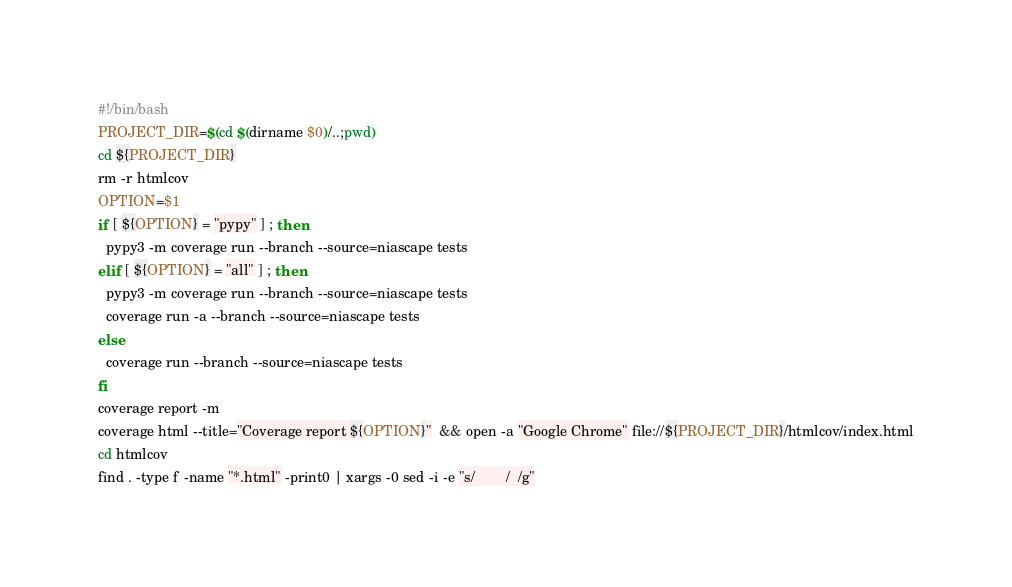<code> <loc_0><loc_0><loc_500><loc_500><_Bash_>#!/bin/bash
PROJECT_DIR=$(cd $(dirname $0)/..;pwd)
cd ${PROJECT_DIR}
rm -r htmlcov
OPTION=$1
if [ ${OPTION} = "pypy" ] ; then
  pypy3 -m coverage run --branch --source=niascape tests
elif [ ${OPTION} = "all" ] ; then
  pypy3 -m coverage run --branch --source=niascape tests
  coverage run -a --branch --source=niascape tests
else
  coverage run --branch --source=niascape tests
fi
coverage report -m 
coverage html --title="Coverage report ${OPTION}"  && open -a "Google Chrome" file://${PROJECT_DIR}/htmlcov/index.html
cd htmlcov
find . -type f -name "*.html" -print0 | xargs -0 sed -i -e "s/        /  /g"
</code> 